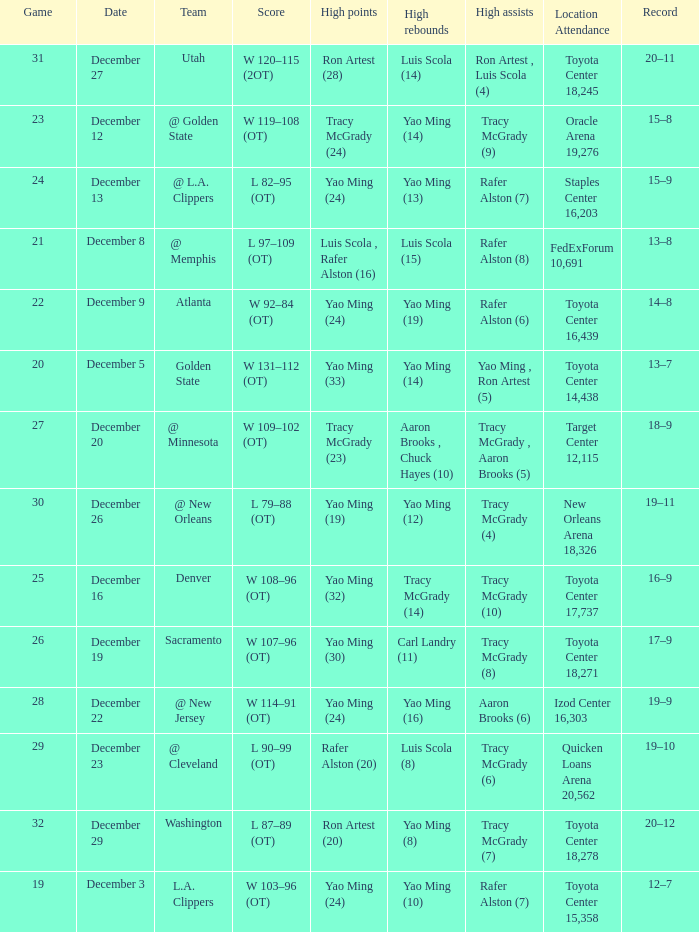When @ new orleans is the team who has the highest amount of rebounds? Yao Ming (12). 